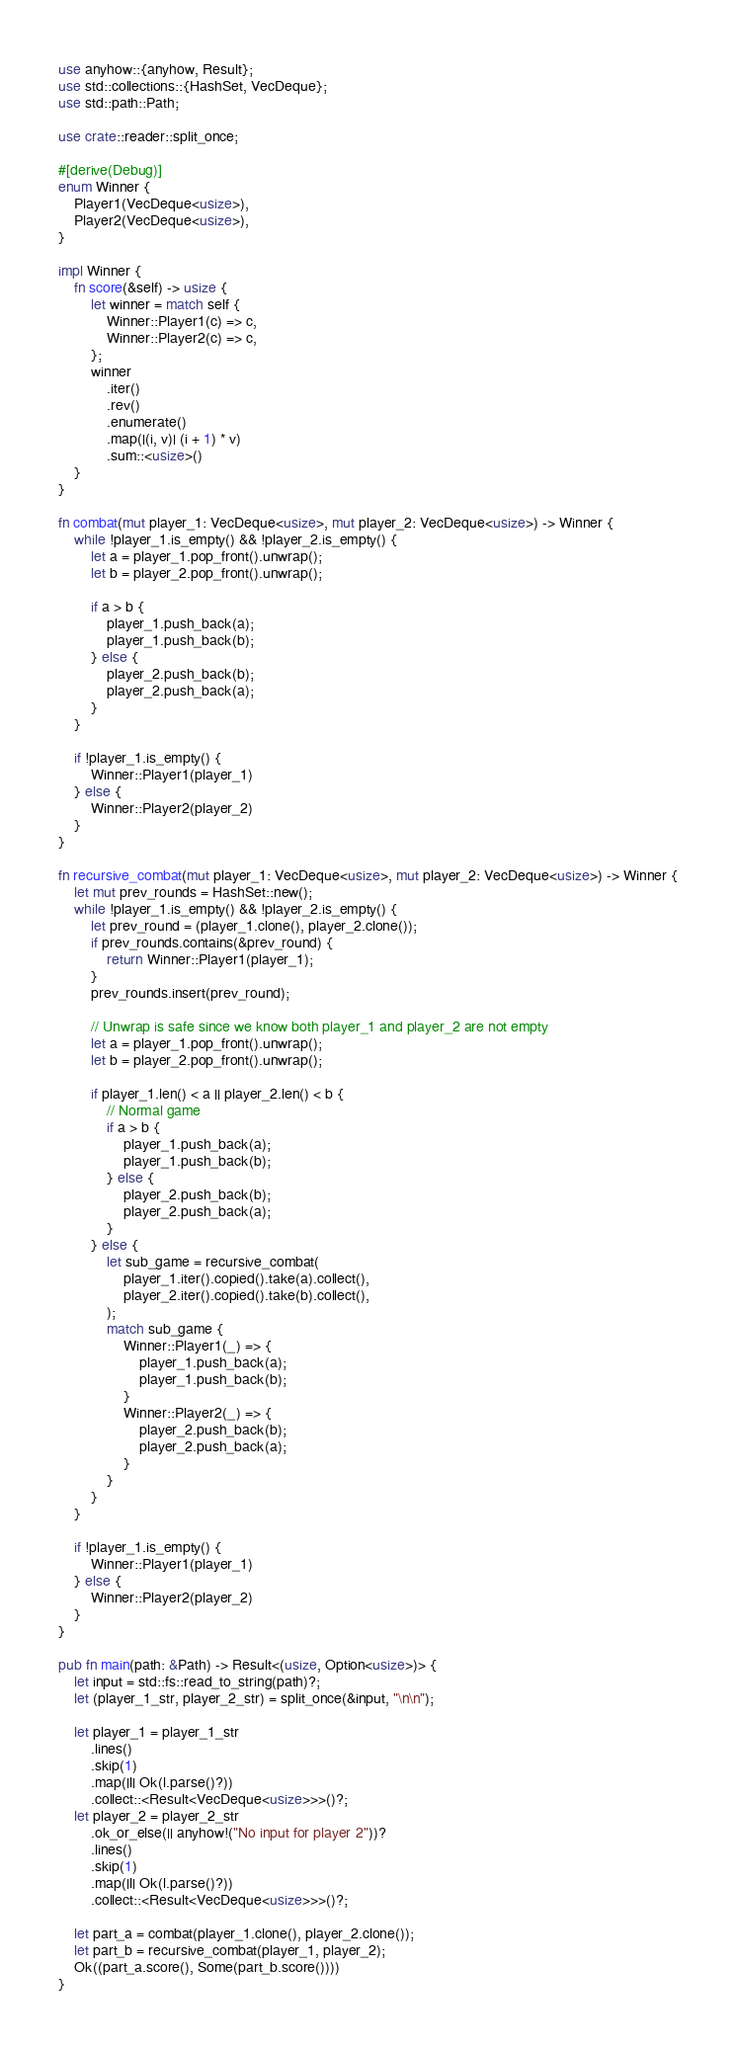Convert code to text. <code><loc_0><loc_0><loc_500><loc_500><_Rust_>use anyhow::{anyhow, Result};
use std::collections::{HashSet, VecDeque};
use std::path::Path;

use crate::reader::split_once;

#[derive(Debug)]
enum Winner {
    Player1(VecDeque<usize>),
    Player2(VecDeque<usize>),
}

impl Winner {
    fn score(&self) -> usize {
        let winner = match self {
            Winner::Player1(c) => c,
            Winner::Player2(c) => c,
        };
        winner
            .iter()
            .rev()
            .enumerate()
            .map(|(i, v)| (i + 1) * v)
            .sum::<usize>()
    }
}

fn combat(mut player_1: VecDeque<usize>, mut player_2: VecDeque<usize>) -> Winner {
    while !player_1.is_empty() && !player_2.is_empty() {
        let a = player_1.pop_front().unwrap();
        let b = player_2.pop_front().unwrap();

        if a > b {
            player_1.push_back(a);
            player_1.push_back(b);
        } else {
            player_2.push_back(b);
            player_2.push_back(a);
        }
    }

    if !player_1.is_empty() {
        Winner::Player1(player_1)
    } else {
        Winner::Player2(player_2)
    }
}

fn recursive_combat(mut player_1: VecDeque<usize>, mut player_2: VecDeque<usize>) -> Winner {
    let mut prev_rounds = HashSet::new();
    while !player_1.is_empty() && !player_2.is_empty() {
        let prev_round = (player_1.clone(), player_2.clone());
        if prev_rounds.contains(&prev_round) {
            return Winner::Player1(player_1);
        }
        prev_rounds.insert(prev_round);

        // Unwrap is safe since we know both player_1 and player_2 are not empty
        let a = player_1.pop_front().unwrap();
        let b = player_2.pop_front().unwrap();

        if player_1.len() < a || player_2.len() < b {
            // Normal game
            if a > b {
                player_1.push_back(a);
                player_1.push_back(b);
            } else {
                player_2.push_back(b);
                player_2.push_back(a);
            }
        } else {
            let sub_game = recursive_combat(
                player_1.iter().copied().take(a).collect(),
                player_2.iter().copied().take(b).collect(),
            );
            match sub_game {
                Winner::Player1(_) => {
                    player_1.push_back(a);
                    player_1.push_back(b);
                }
                Winner::Player2(_) => {
                    player_2.push_back(b);
                    player_2.push_back(a);
                }
            }
        }
    }

    if !player_1.is_empty() {
        Winner::Player1(player_1)
    } else {
        Winner::Player2(player_2)
    }
}

pub fn main(path: &Path) -> Result<(usize, Option<usize>)> {
    let input = std::fs::read_to_string(path)?;
    let (player_1_str, player_2_str) = split_once(&input, "\n\n");

    let player_1 = player_1_str
        .lines()
        .skip(1)
        .map(|l| Ok(l.parse()?))
        .collect::<Result<VecDeque<usize>>>()?;
    let player_2 = player_2_str
        .ok_or_else(|| anyhow!("No input for player 2"))?
        .lines()
        .skip(1)
        .map(|l| Ok(l.parse()?))
        .collect::<Result<VecDeque<usize>>>()?;

    let part_a = combat(player_1.clone(), player_2.clone());
    let part_b = recursive_combat(player_1, player_2);
    Ok((part_a.score(), Some(part_b.score())))
}
</code> 